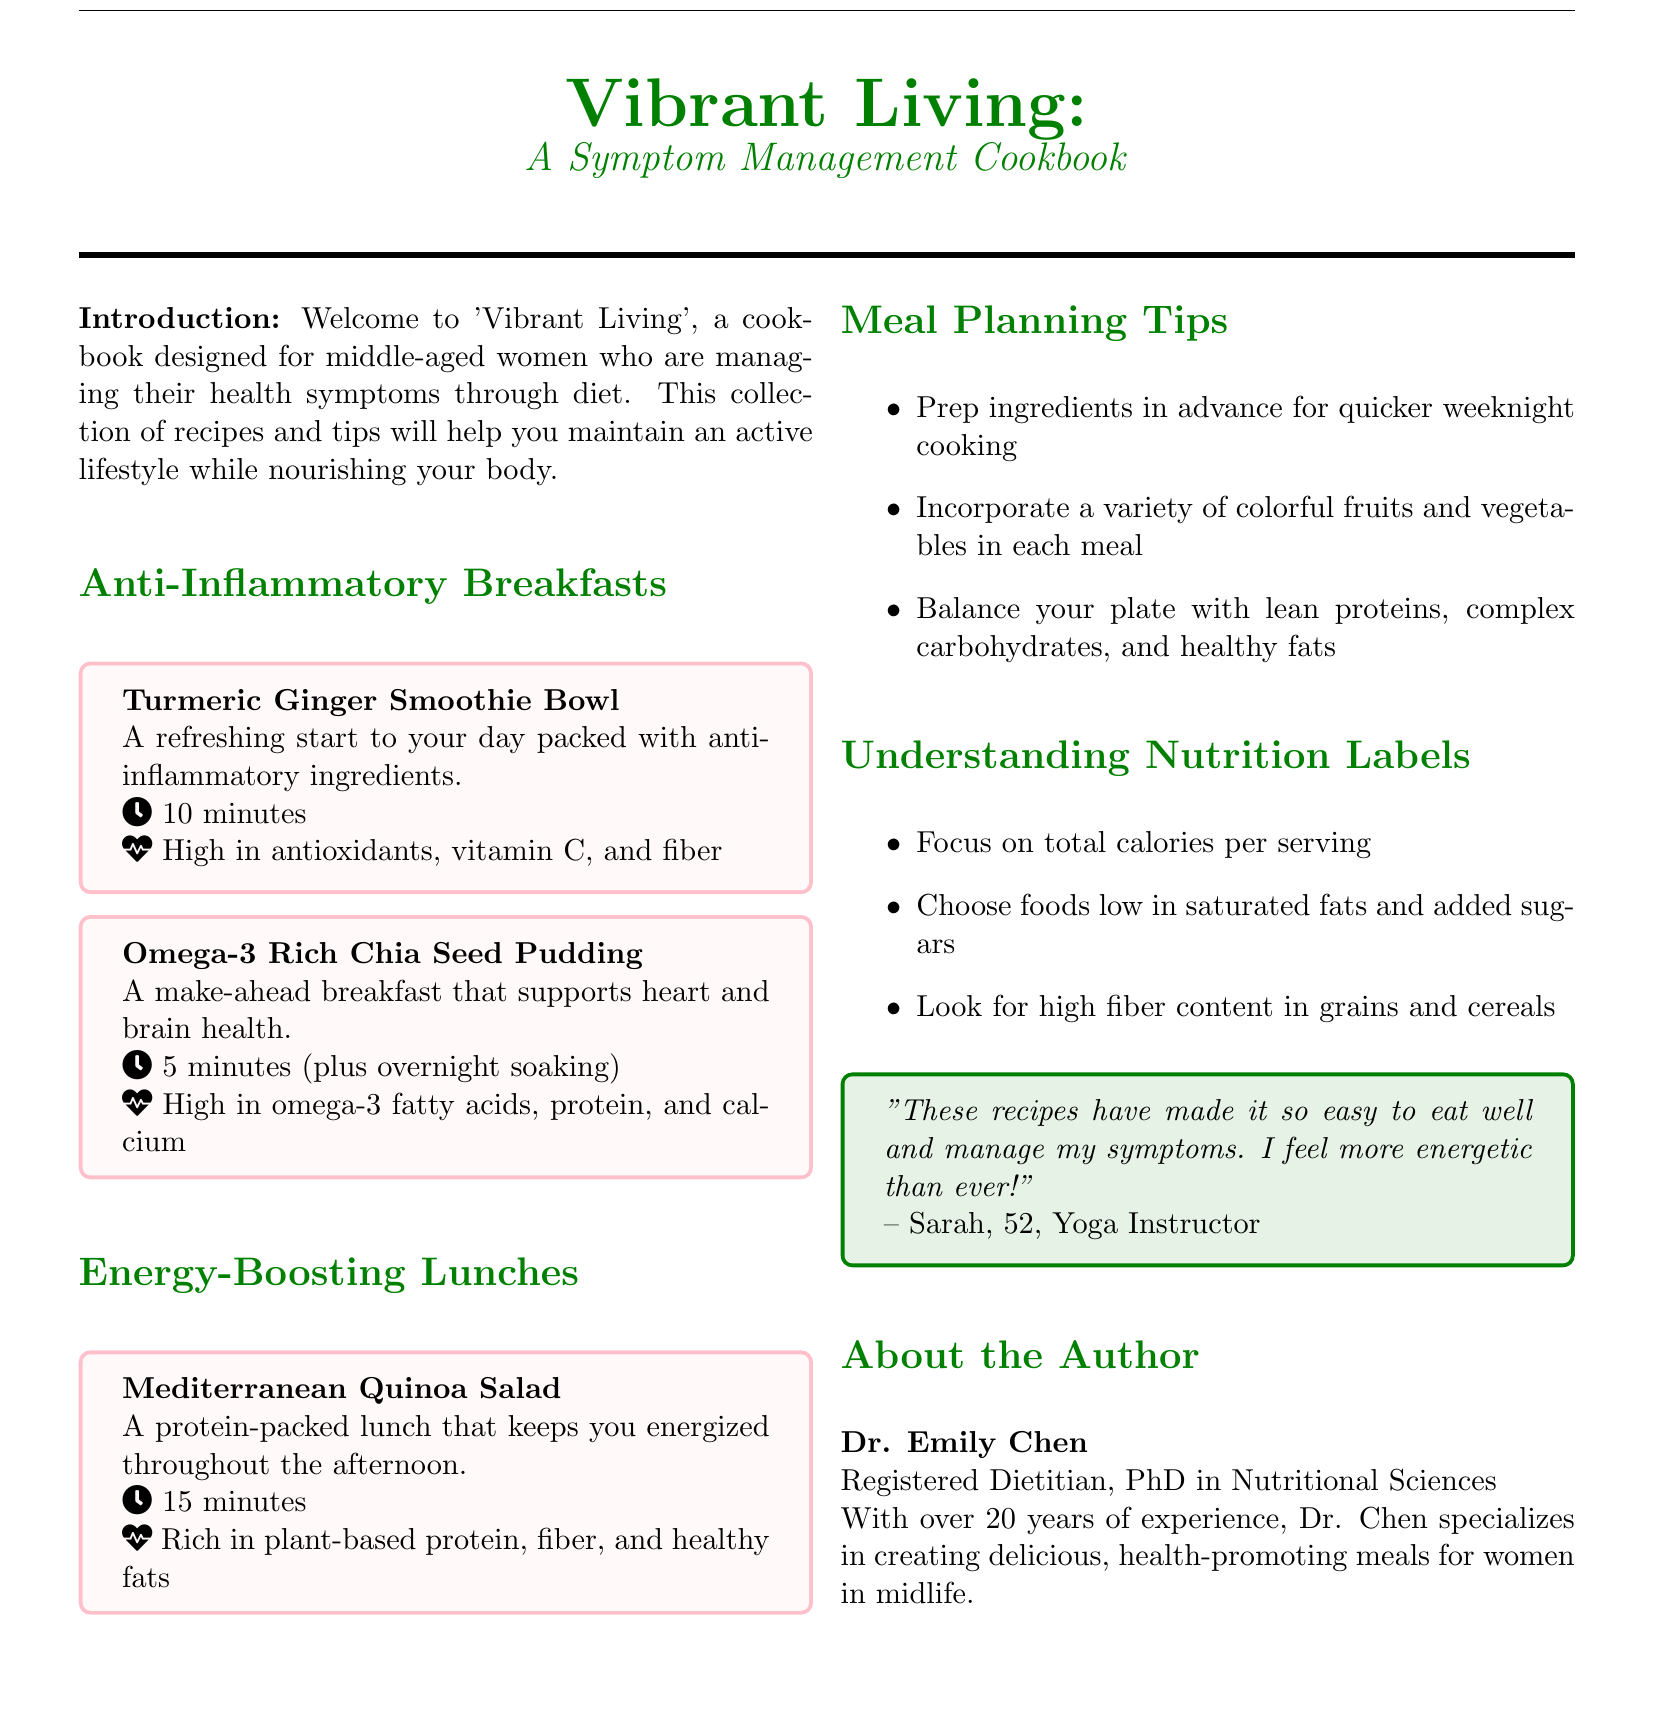What is the name of the cookbook? The title of the cookbook is presented prominently at the top of the document.
Answer: Vibrant Living Who is the target audience for this cookbook? The introduction describes the target audience for this cookbook.
Answer: Middle-aged women What type of recipe is the Turmeric Ginger Smoothie Bowl? This recipe is categorized under breakfast recipes in the document.
Answer: Anti-Inflammatory Breakfasts How long does it take to prepare the Omega-3 Rich Chia Seed Pudding? The document states the preparation time for this recipe.
Answer: 5 minutes (plus overnight soaking) What is one benefit of the Mediterranean Quinoa Salad? The description mentions the nutritional attributes of this salad.
Answer: Energized throughout the afternoon Name one meal planning tip provided in the document. The document lists several tips for meal planning.
Answer: Prep ingredients in advance What should you focus on in nutrition labels? The document gives advice on understanding nutrition labels.
Answer: Total calories per serving How many years of experience does Dr. Emily Chen have? The author bio mentions the time spent in her field.
Answer: Over 20 years What is included in the introduction section? The introduction provides an overview of the cookbook’s purpose and audience.
Answer: Welcome to 'Vibrant Living' Which category does the section titled "Energy-Boosting Lunches" belong to? The section is clearly labeled in the catalog.
Answer: Lunches 